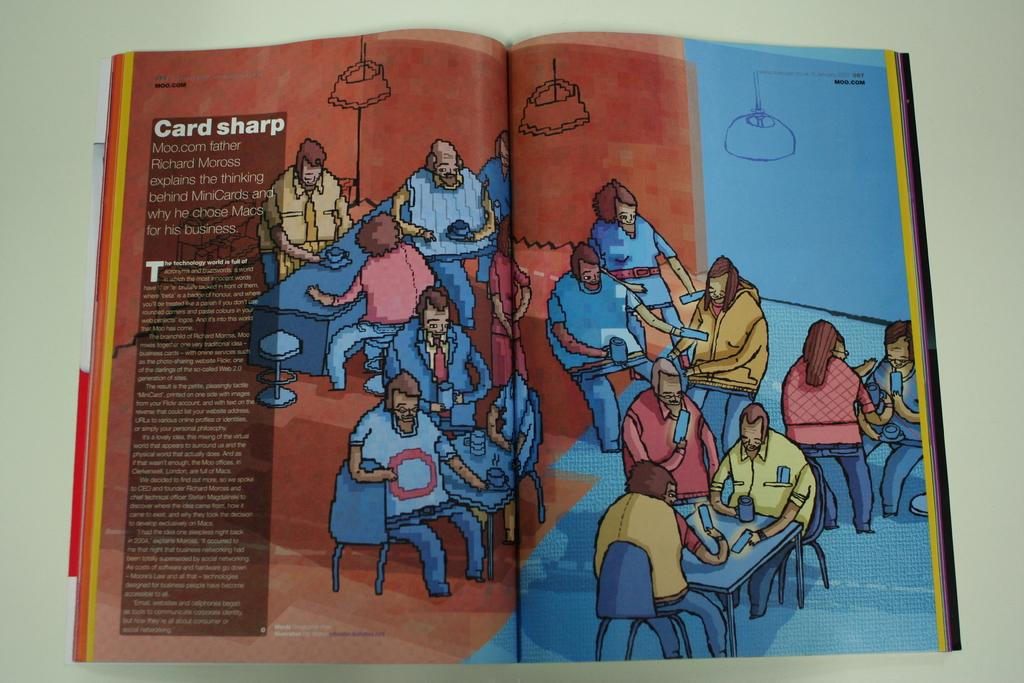Provide a one-sentence caption for the provided image. an open book with an excerpt that says card sharp with several drawings of people. 